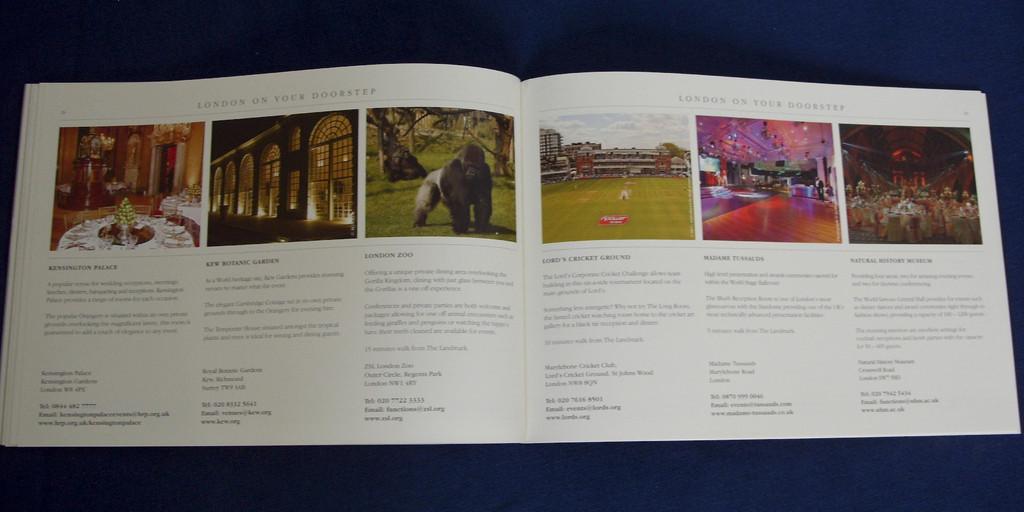What zoo is mentioned here?
Your answer should be very brief. London. 